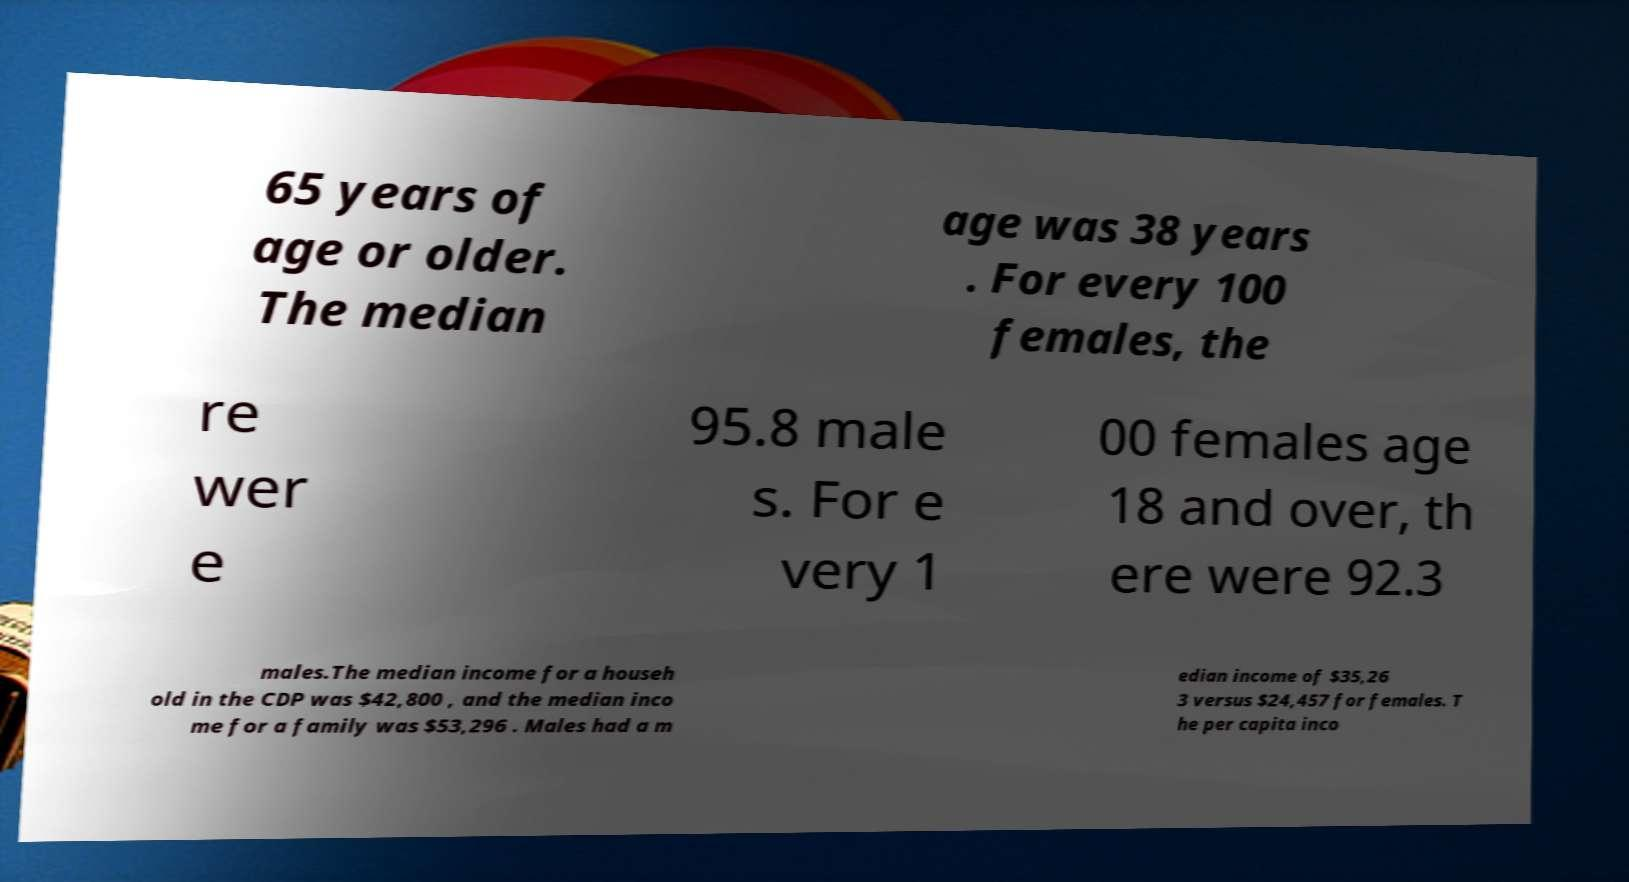Can you read and provide the text displayed in the image?This photo seems to have some interesting text. Can you extract and type it out for me? 65 years of age or older. The median age was 38 years . For every 100 females, the re wer e 95.8 male s. For e very 1 00 females age 18 and over, th ere were 92.3 males.The median income for a househ old in the CDP was $42,800 , and the median inco me for a family was $53,296 . Males had a m edian income of $35,26 3 versus $24,457 for females. T he per capita inco 